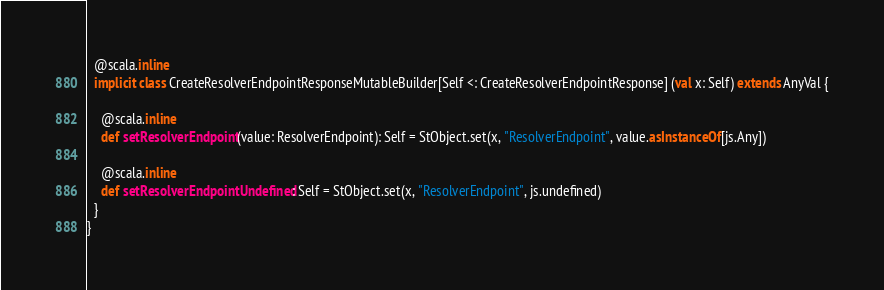<code> <loc_0><loc_0><loc_500><loc_500><_Scala_>  @scala.inline
  implicit class CreateResolverEndpointResponseMutableBuilder[Self <: CreateResolverEndpointResponse] (val x: Self) extends AnyVal {
    
    @scala.inline
    def setResolverEndpoint(value: ResolverEndpoint): Self = StObject.set(x, "ResolverEndpoint", value.asInstanceOf[js.Any])
    
    @scala.inline
    def setResolverEndpointUndefined: Self = StObject.set(x, "ResolverEndpoint", js.undefined)
  }
}
</code> 